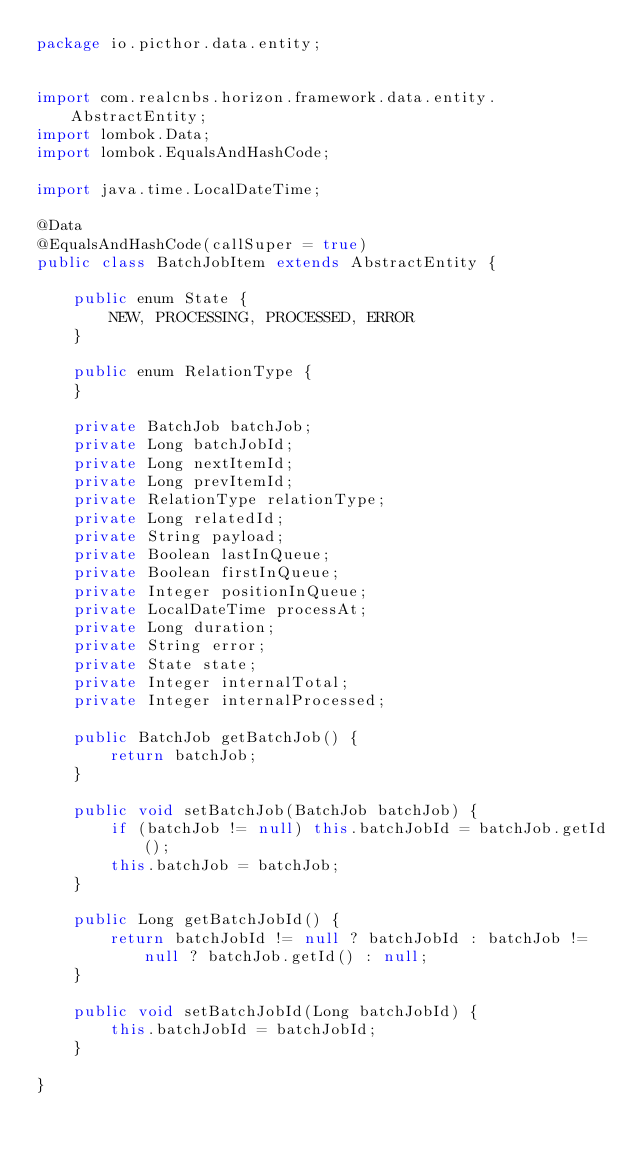<code> <loc_0><loc_0><loc_500><loc_500><_Java_>package io.picthor.data.entity;


import com.realcnbs.horizon.framework.data.entity.AbstractEntity;
import lombok.Data;
import lombok.EqualsAndHashCode;

import java.time.LocalDateTime;

@Data
@EqualsAndHashCode(callSuper = true)
public class BatchJobItem extends AbstractEntity {

    public enum State {
        NEW, PROCESSING, PROCESSED, ERROR
    }

    public enum RelationType {
    }

    private BatchJob batchJob;
    private Long batchJobId;
    private Long nextItemId;
    private Long prevItemId;
    private RelationType relationType;
    private Long relatedId;
    private String payload;
    private Boolean lastInQueue;
    private Boolean firstInQueue;
    private Integer positionInQueue;
    private LocalDateTime processAt;
    private Long duration;
    private String error;
    private State state;
    private Integer internalTotal;
    private Integer internalProcessed;

    public BatchJob getBatchJob() {
        return batchJob;
    }

    public void setBatchJob(BatchJob batchJob) {
        if (batchJob != null) this.batchJobId = batchJob.getId();
        this.batchJob = batchJob;
    }

    public Long getBatchJobId() {
        return batchJobId != null ? batchJobId : batchJob != null ? batchJob.getId() : null;
    }

    public void setBatchJobId(Long batchJobId) {
        this.batchJobId = batchJobId;
    }

}
</code> 